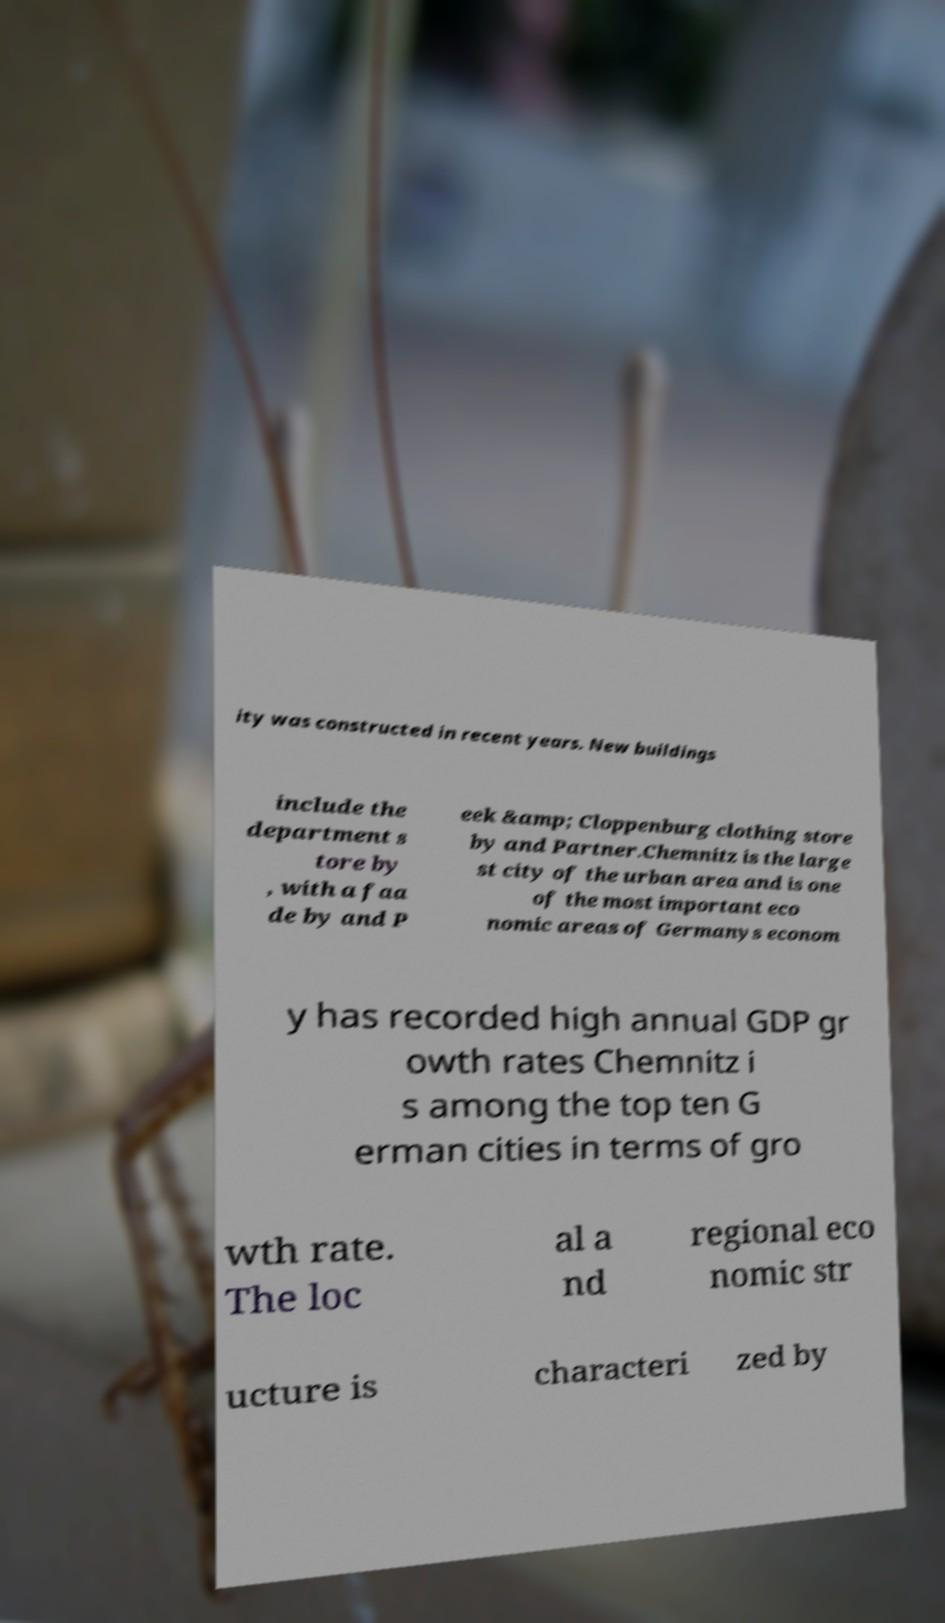There's text embedded in this image that I need extracted. Can you transcribe it verbatim? ity was constructed in recent years. New buildings include the department s tore by , with a faa de by and P eek &amp; Cloppenburg clothing store by and Partner.Chemnitz is the large st city of the urban area and is one of the most important eco nomic areas of Germanys econom y has recorded high annual GDP gr owth rates Chemnitz i s among the top ten G erman cities in terms of gro wth rate. The loc al a nd regional eco nomic str ucture is characteri zed by 